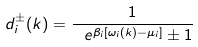Convert formula to latex. <formula><loc_0><loc_0><loc_500><loc_500>d _ { i } ^ { \pm } ( k ) = \frac { 1 } { \ e ^ { \beta _ { i } [ \omega _ { i } ( k ) - \mu _ { i } ] } \pm 1 }</formula> 